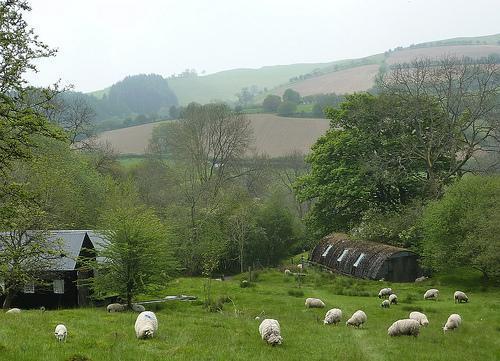How many buildings are in the picture?
Give a very brief answer. 2. 